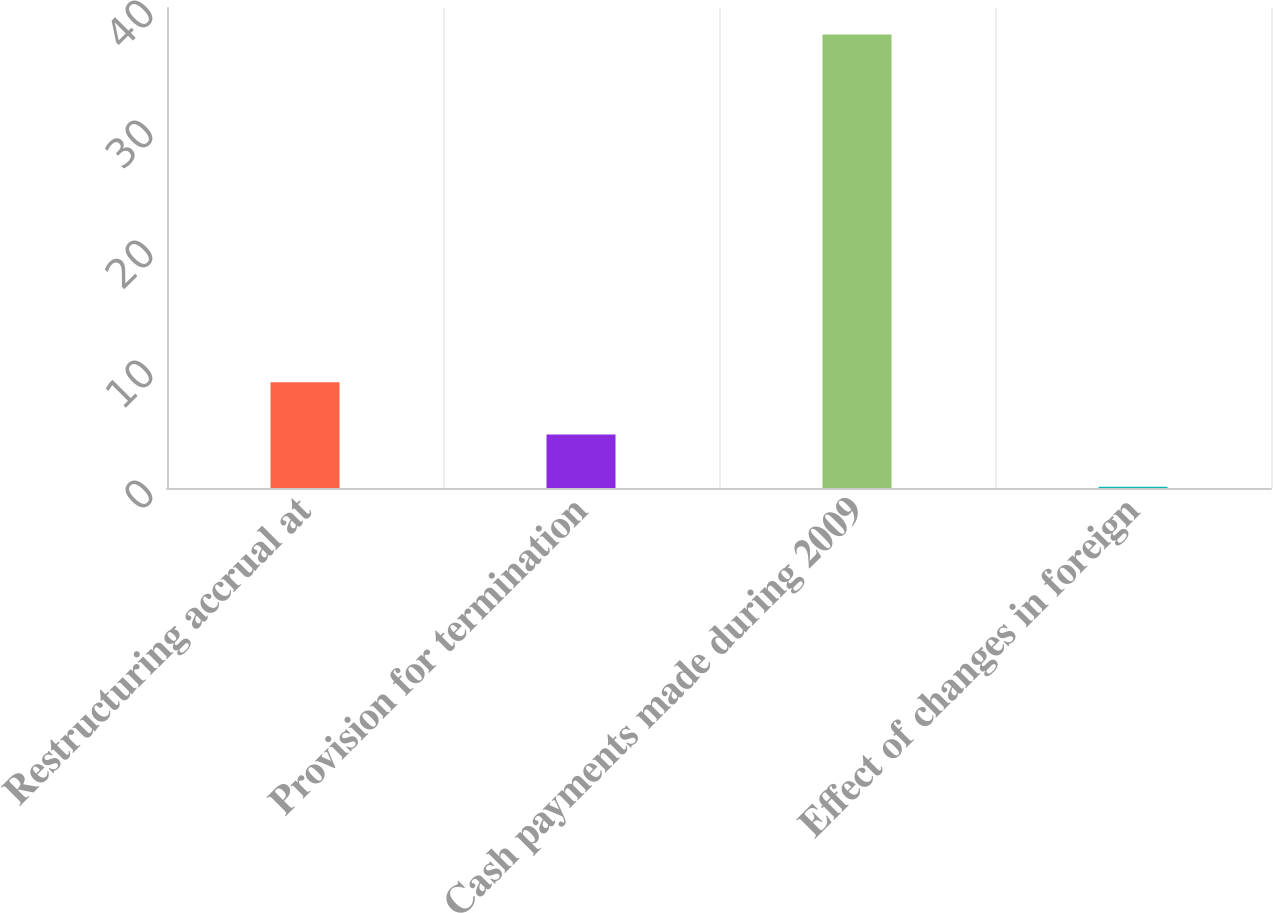<chart> <loc_0><loc_0><loc_500><loc_500><bar_chart><fcel>Restructuring accrual at<fcel>Provision for termination<fcel>Cash payments made during 2009<fcel>Effect of changes in foreign<nl><fcel>8.82<fcel>4.46<fcel>37.8<fcel>0.1<nl></chart> 